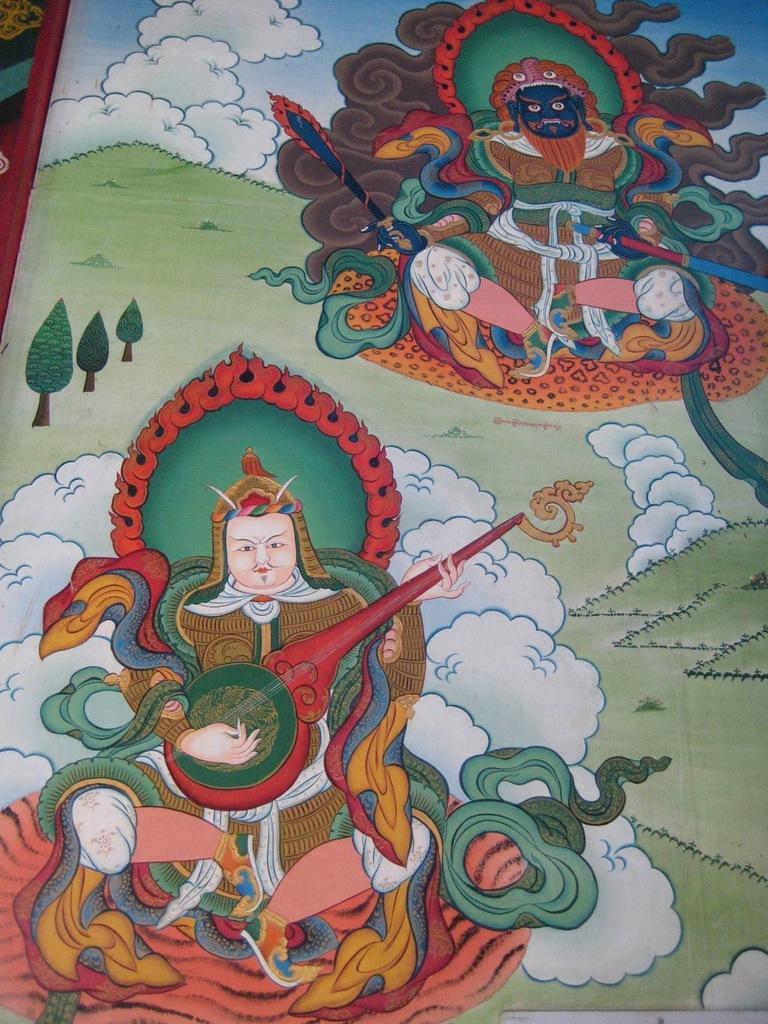Please provide a concise description of this image. In the image we can see the painting. In the painting we can see the people holding a musical instrument and sword in hand. Here we can see the grass and the sky. 